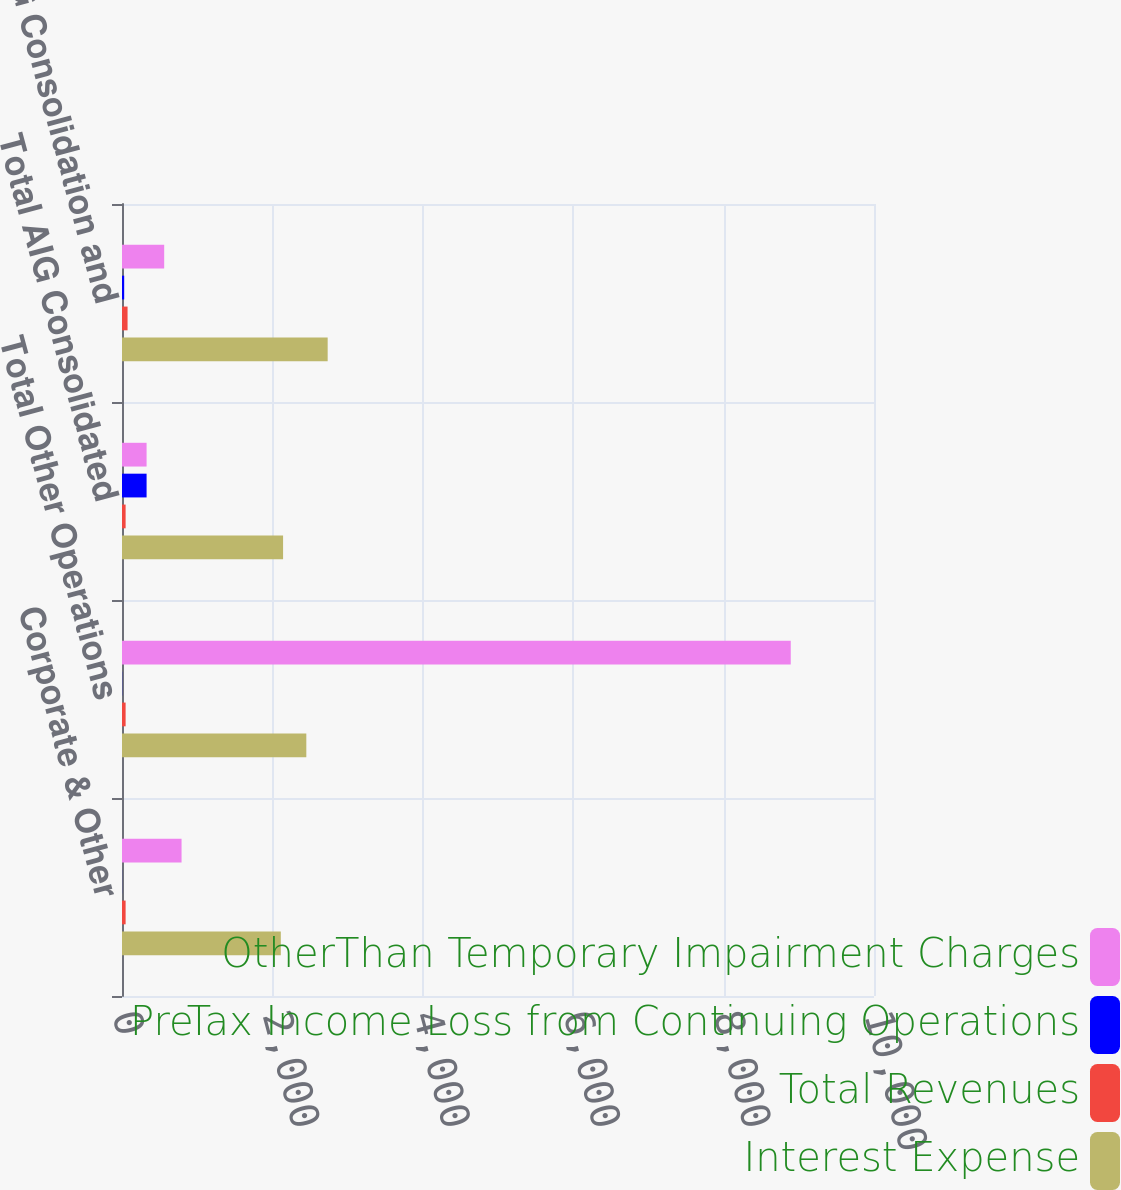Convert chart to OTSL. <chart><loc_0><loc_0><loc_500><loc_500><stacked_bar_chart><ecel><fcel>Corporate & Other<fcel>Total Other Operations<fcel>Total AIG Consolidated<fcel>AIG Consolidation and<nl><fcel>OtherThan Temporary Impairment Charges<fcel>792<fcel>8893<fcel>327<fcel>561<nl><fcel>PreTax Income Loss from Continuing Operations<fcel>1<fcel>2<fcel>327<fcel>29<nl><fcel>Total Revenues<fcel>48<fcel>48<fcel>48<fcel>74<nl><fcel>Interest Expense<fcel>2112<fcel>2451<fcel>2142<fcel>2735<nl></chart> 